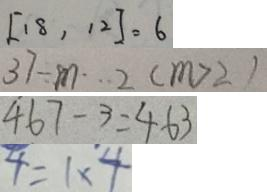Convert formula to latex. <formula><loc_0><loc_0><loc_500><loc_500>[ 1 8 , 1 2 ] = 6 
 3 7 \div m \cdots 2 ( m > 2 ) 
 4 6 7 - 3 = 4 6 3 
 4 = 1 \times 4</formula> 